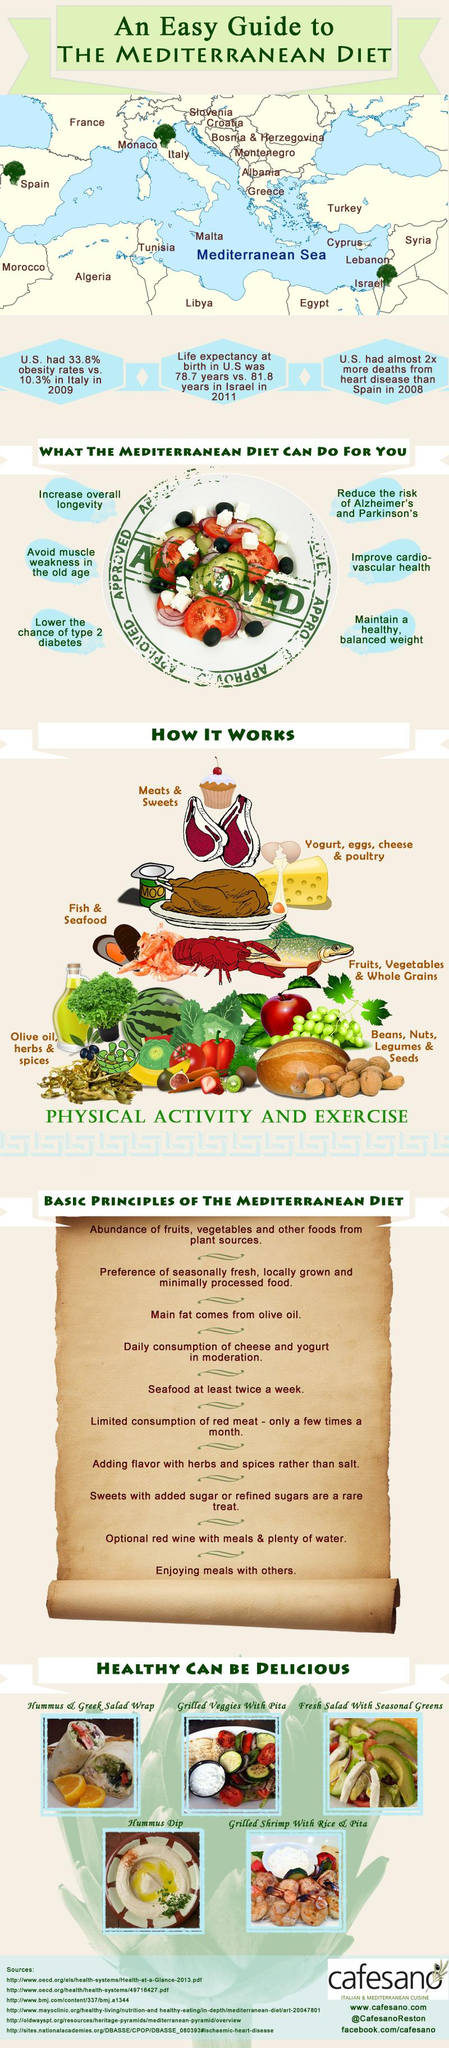Outline some significant characteristics in this image. There are 10 principles for the Mediterranean diet. The Mediterranean diet has 6 uses. 